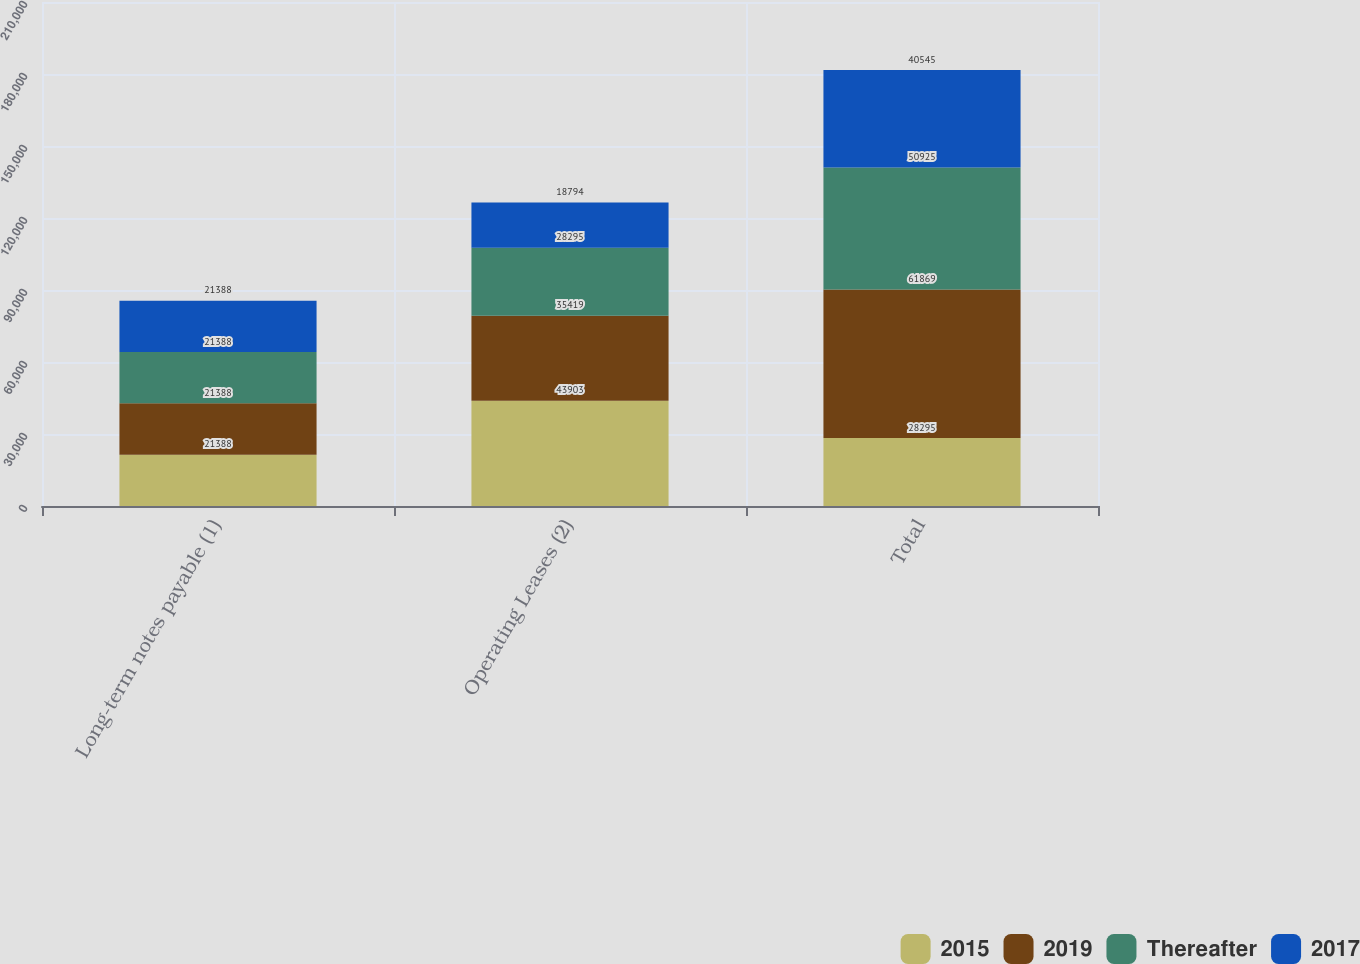Convert chart. <chart><loc_0><loc_0><loc_500><loc_500><stacked_bar_chart><ecel><fcel>Long-term notes payable (1)<fcel>Operating Leases (2)<fcel>Total<nl><fcel>2015<fcel>21388<fcel>43903<fcel>28295<nl><fcel>2019<fcel>21388<fcel>35419<fcel>61869<nl><fcel>Thereafter<fcel>21388<fcel>28295<fcel>50925<nl><fcel>2017<fcel>21388<fcel>18794<fcel>40545<nl></chart> 